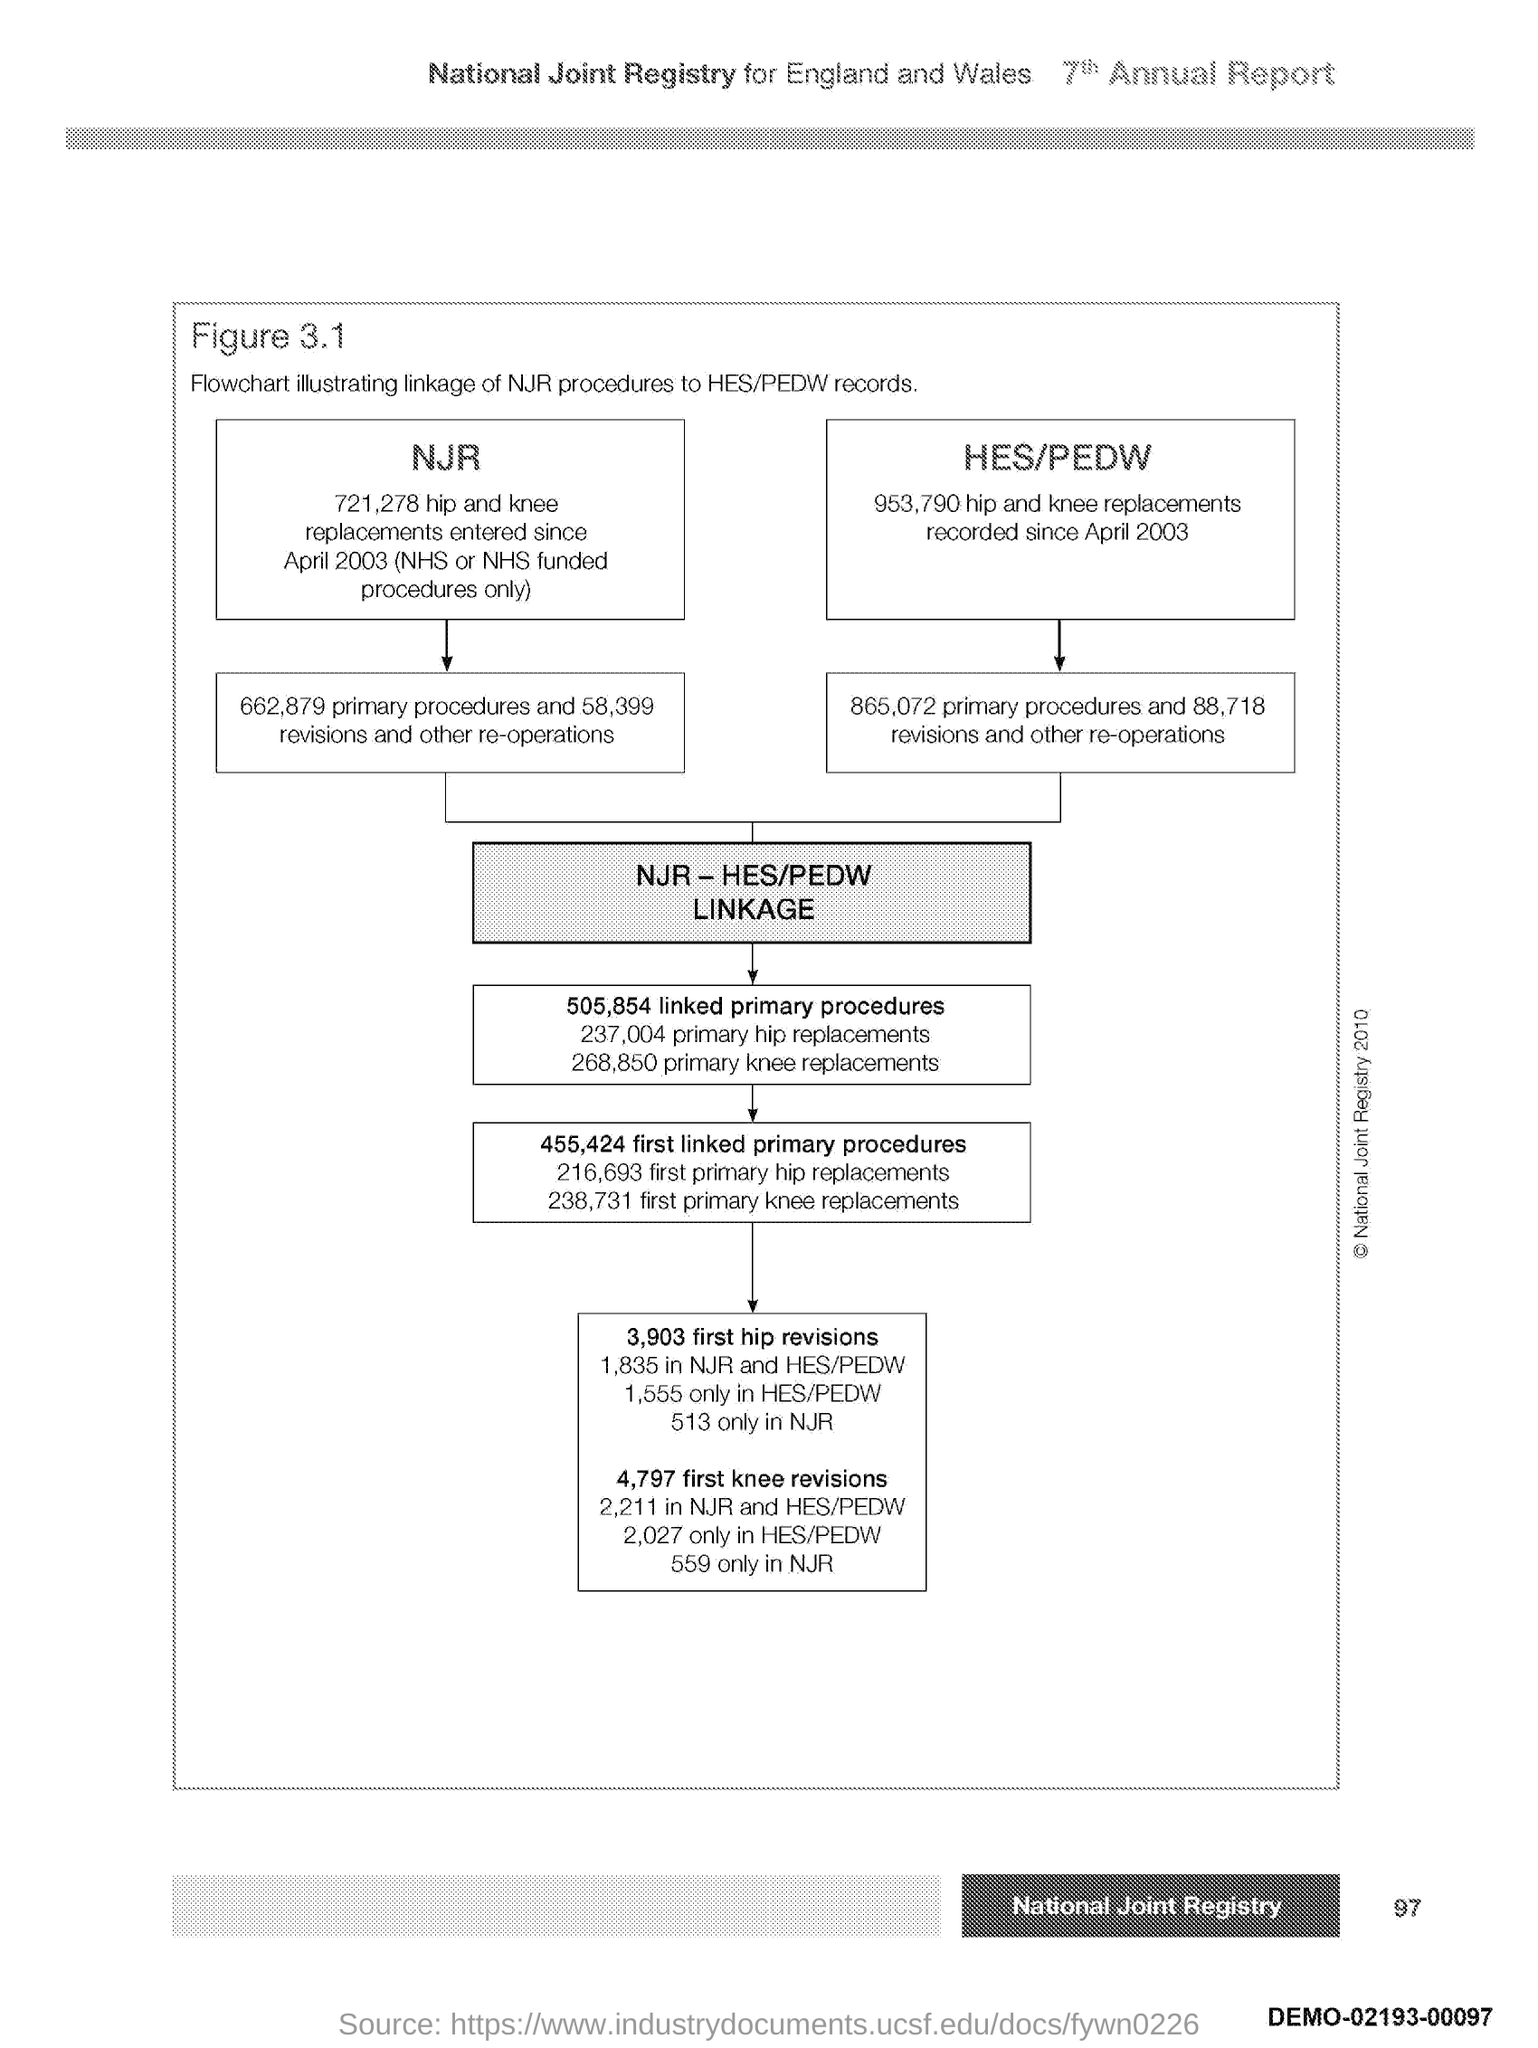What is the Page Number?
Offer a very short reply. 97. 